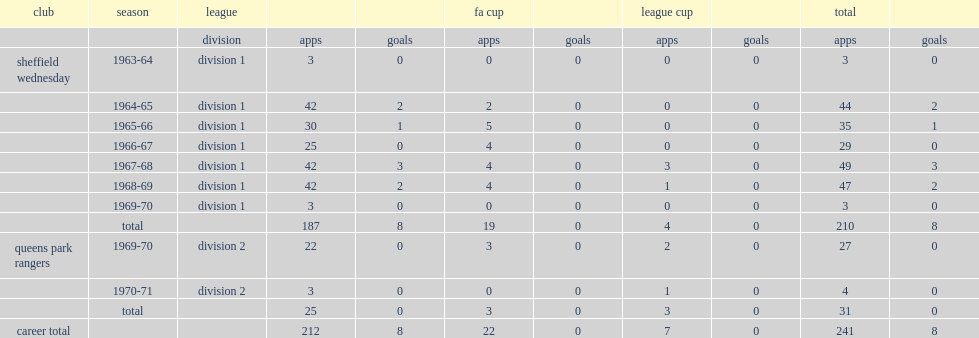How many goals did vic mobley score for wednesday totally? 8.0. 